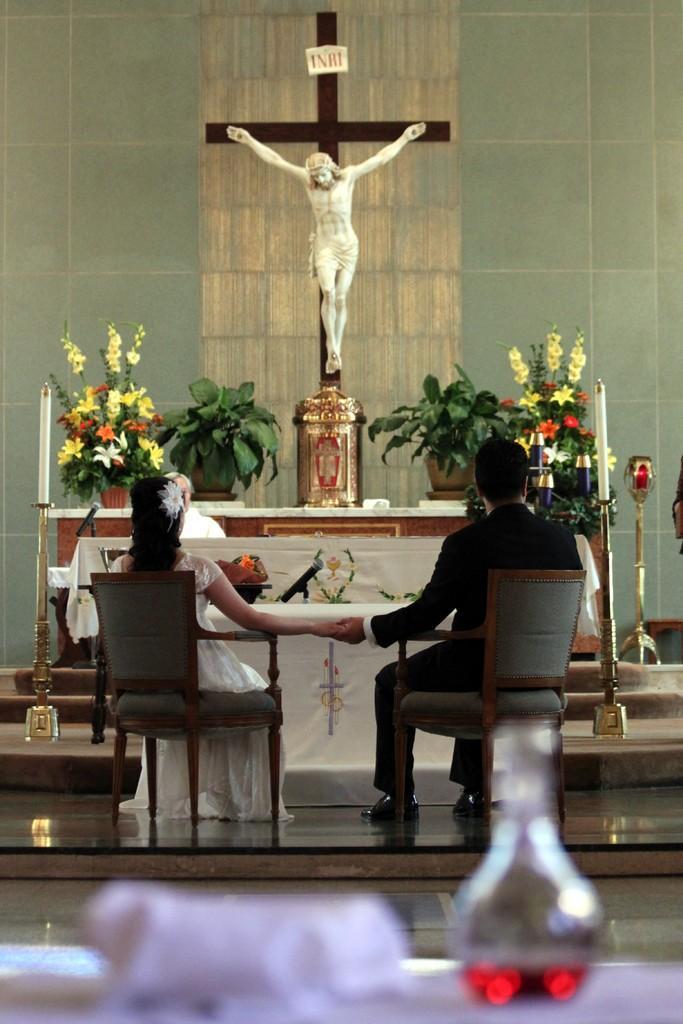Can you describe this image briefly? Here we can see a couple sitting on a chair and they hold their hand each other. Here we can see a person sitting on a chair. In the background we can see a clay pot and a jesus statue. 